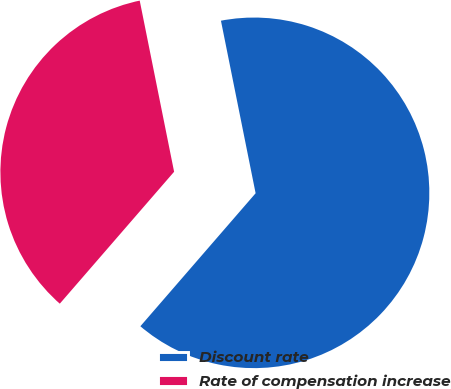<chart> <loc_0><loc_0><loc_500><loc_500><pie_chart><fcel>Discount rate<fcel>Rate of compensation increase<nl><fcel>64.52%<fcel>35.48%<nl></chart> 